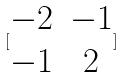<formula> <loc_0><loc_0><loc_500><loc_500>[ \begin{matrix} - 2 & - 1 \\ - 1 & 2 \end{matrix} ]</formula> 